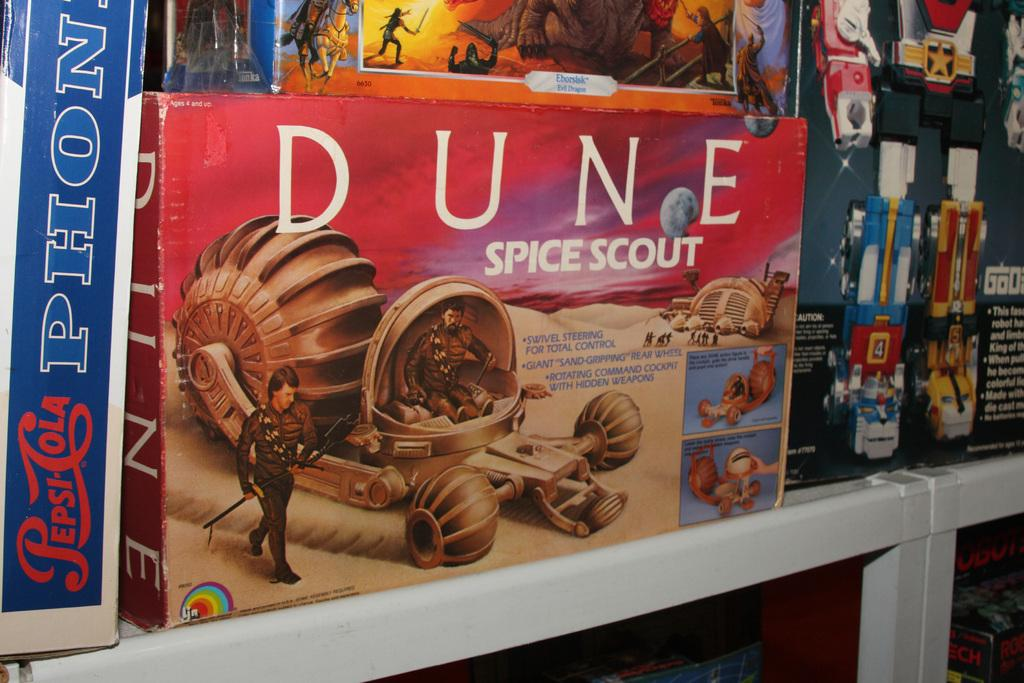What is located on the platform in the image? There is a box on a platform in the image. Who or what can be seen in the image? There are people visible in the image. What else can be seen in the image besides the box and people? There are some objects in the image. Can you describe any text visible in the image? There is text on the box or platform in the image. What can be seen in the background of the image? There are objects visible in the background of the image. What type of string can be seen tied to the box in the image? There is no string tied to the box in the image. What achievements has the achiever in the image accomplished? There is no achiever or mention of achievements in the image. 